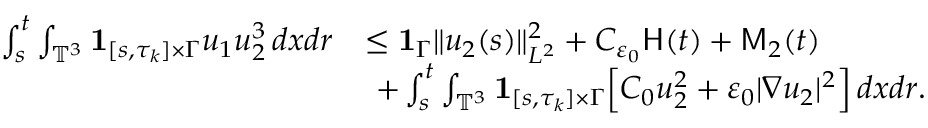<formula> <loc_0><loc_0><loc_500><loc_500>\begin{array} { r l } { \int _ { s } ^ { t } \int _ { \mathbb { T } ^ { 3 } } { 1 } _ { [ s , \tau _ { k } ] \times \Gamma } u _ { 1 } u _ { 2 } ^ { 3 } \, d x d r } & { \leq { 1 } _ { \Gamma } \| u _ { 2 } ( s ) \| _ { L ^ { 2 } } ^ { 2 } + C _ { \varepsilon _ { 0 } } H ( t ) + M _ { 2 } ( t ) } \\ & { \ + \int _ { s } ^ { t } \int _ { \mathbb { T } ^ { 3 } } { 1 } _ { [ s , \tau _ { k } ] \times \Gamma } \left [ C _ { 0 } u _ { 2 } ^ { 2 } + \varepsilon _ { 0 } | \nabla u _ { 2 } | ^ { 2 } \right ] \, d x d r . } \end{array}</formula> 